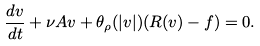<formula> <loc_0><loc_0><loc_500><loc_500>\frac { d v } { d t } + \nu A v + \theta _ { \rho } ( | v | ) ( R ( v ) - f ) = 0 .</formula> 